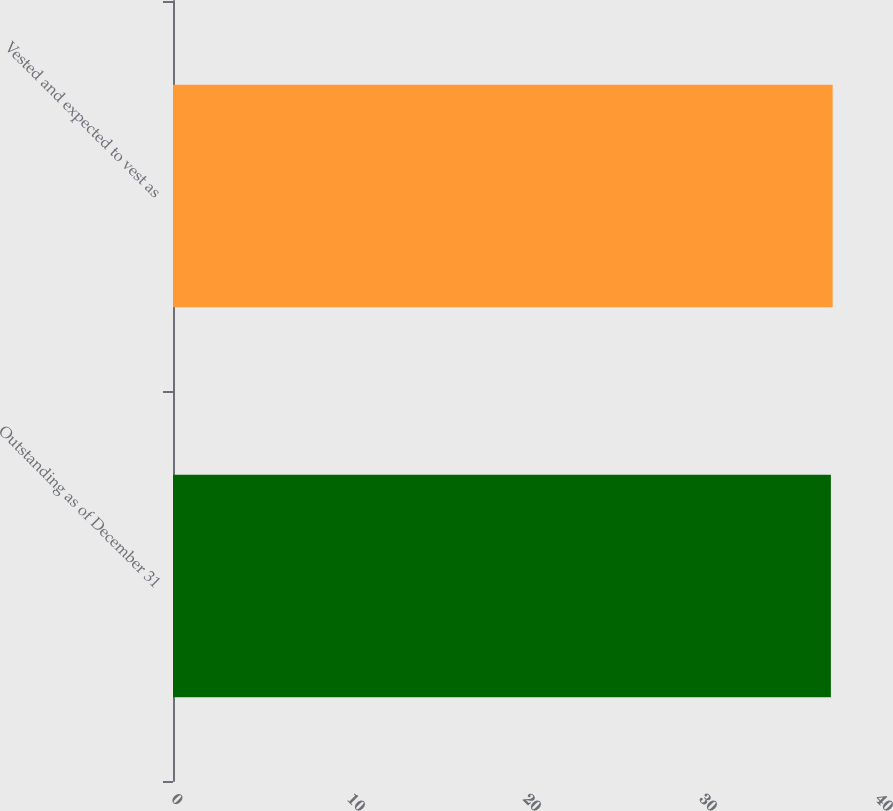Convert chart. <chart><loc_0><loc_0><loc_500><loc_500><bar_chart><fcel>Outstanding as of December 31<fcel>Vested and expected to vest as<nl><fcel>37.38<fcel>37.48<nl></chart> 